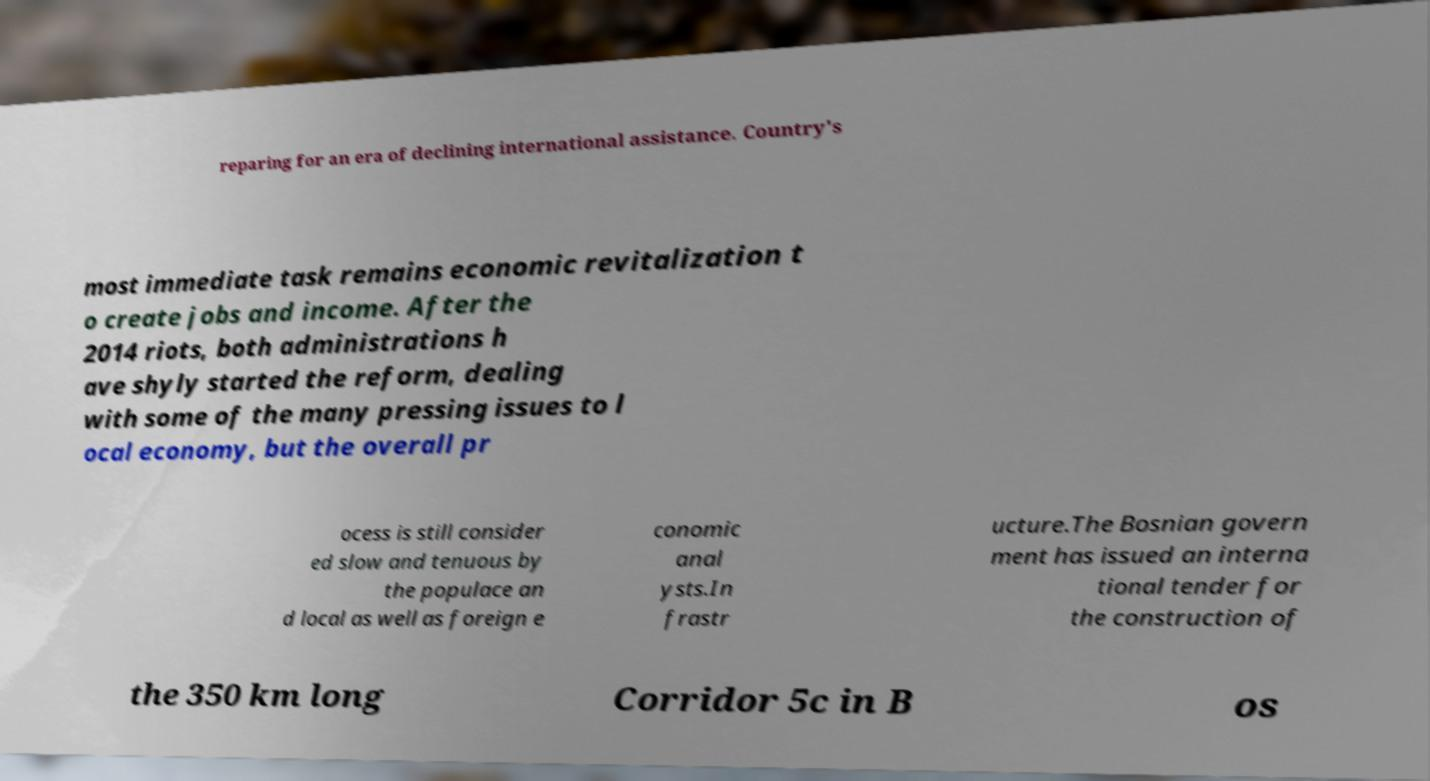Please read and relay the text visible in this image. What does it say? reparing for an era of declining international assistance. Country's most immediate task remains economic revitalization t o create jobs and income. After the 2014 riots, both administrations h ave shyly started the reform, dealing with some of the many pressing issues to l ocal economy, but the overall pr ocess is still consider ed slow and tenuous by the populace an d local as well as foreign e conomic anal ysts.In frastr ucture.The Bosnian govern ment has issued an interna tional tender for the construction of the 350 km long Corridor 5c in B os 